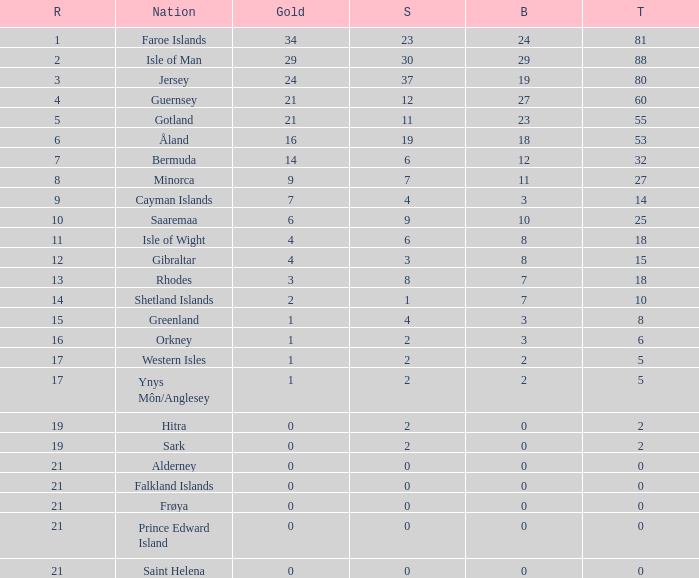How many Silver medals were won in total by all those with more than 3 bronze and exactly 16 gold? 19.0. 